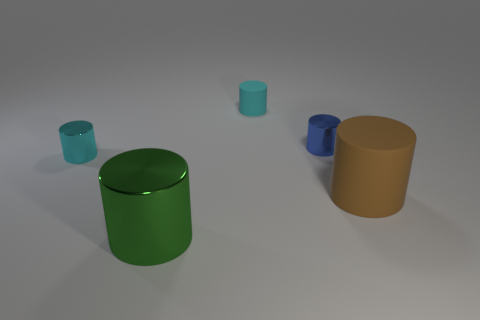Are there any distinct textures or patterns on the objects? The objects do not exhibit any distinct textures or patterns; they have smooth surfaces without any visible grain or design, giving them a simplistic aesthetic. 